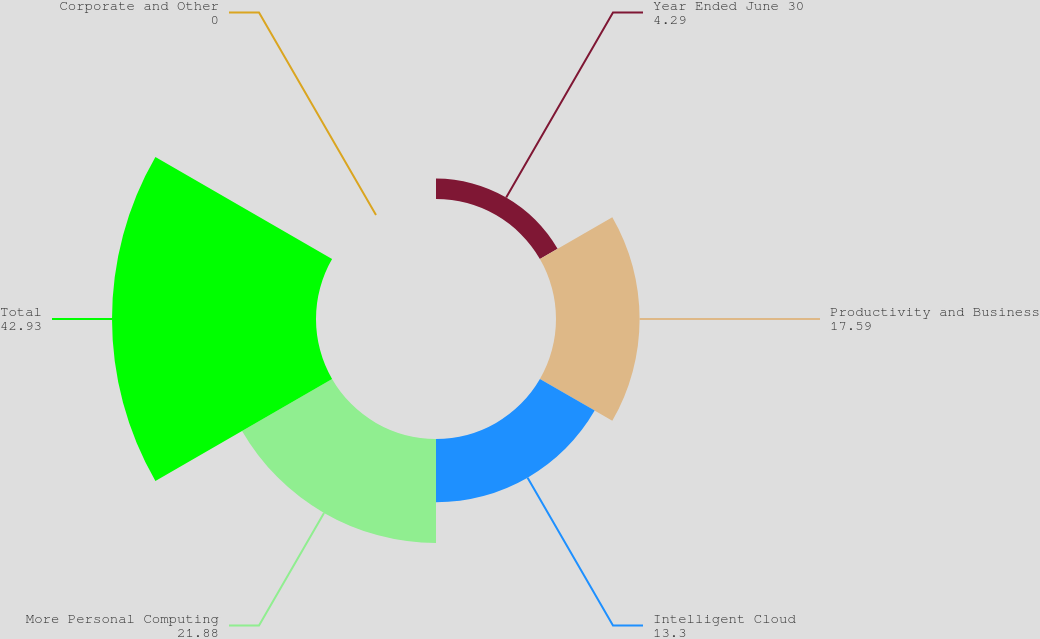Convert chart to OTSL. <chart><loc_0><loc_0><loc_500><loc_500><pie_chart><fcel>Year Ended June 30<fcel>Productivity and Business<fcel>Intelligent Cloud<fcel>More Personal Computing<fcel>Total<fcel>Corporate and Other<nl><fcel>4.29%<fcel>17.59%<fcel>13.3%<fcel>21.88%<fcel>42.93%<fcel>0.0%<nl></chart> 